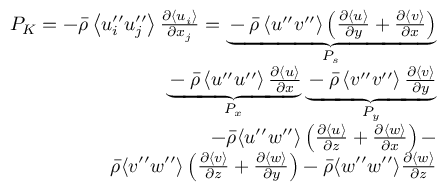Convert formula to latex. <formula><loc_0><loc_0><loc_500><loc_500>\begin{array} { r } { P _ { K } = - \bar { \rho } \left \langle u _ { i } ^ { \prime \prime } u _ { j } ^ { \prime \prime } \right \rangle \frac { \partial \left \langle u _ { i } \right \rangle } { \partial x _ { j } } = \underbrace { - \bar { \rho } \left \langle u ^ { \prime \prime } v ^ { \prime \prime } \right \rangle \left ( \frac { \partial \langle u \rangle } { \partial y } + \frac { \partial \langle v \rangle } { \partial x } \right ) } _ { P _ { s } } } \\ { \underbrace { - \bar { \rho } \left \langle u ^ { \prime \prime } u ^ { \prime \prime } \right \rangle \frac { \partial \langle u \rangle } { \partial x } } _ { P _ { x } } \underbrace { - \bar { \rho } \left \langle v ^ { \prime \prime } v ^ { \prime \prime } \right \rangle \frac { \partial \langle v \rangle } { \partial y } } _ { P _ { y } } } \\ { - \bar { \rho } \langle u ^ { \prime \prime } w ^ { \prime \prime } \rangle \left ( \frac { \partial \langle u \rangle } { \partial z } + \frac { \partial \langle w \rangle } { \partial x } \right ) - } \\ { \bar { \rho } \langle v ^ { \prime \prime } w ^ { \prime \prime } \rangle \left ( \frac { \partial \langle v \rangle } { \partial z } + \frac { \partial \langle w \rangle } { \partial y } \right ) - \bar { \rho } \langle w ^ { \prime \prime } w ^ { \prime \prime } \rangle \frac { \partial \langle w \rangle } { \partial z } } \end{array}</formula> 